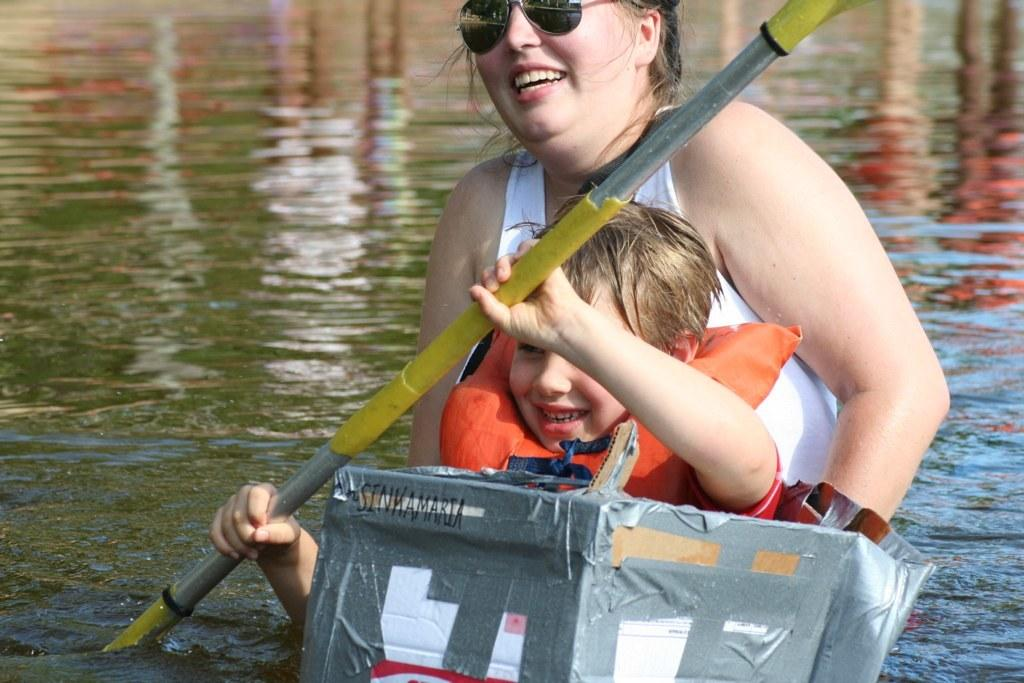What is present in the image that is not a person or a boat? There is water in the image. How many people are in the image? There is a woman and a boy in the image. What is the boy wearing? The boy is wearing a jacket. What is the boy holding in the image? The boy is holding a rod. What protective gear is the woman wearing? The woman is wearing goggles. What type of vehicle is in the image? There is a boat in the image. What type of cable is being used to rake the water in the image? There is no cable or rake present in the image. How many times has the boat been folded in the image? The boat is not folded in the image; it is a solid structure. 